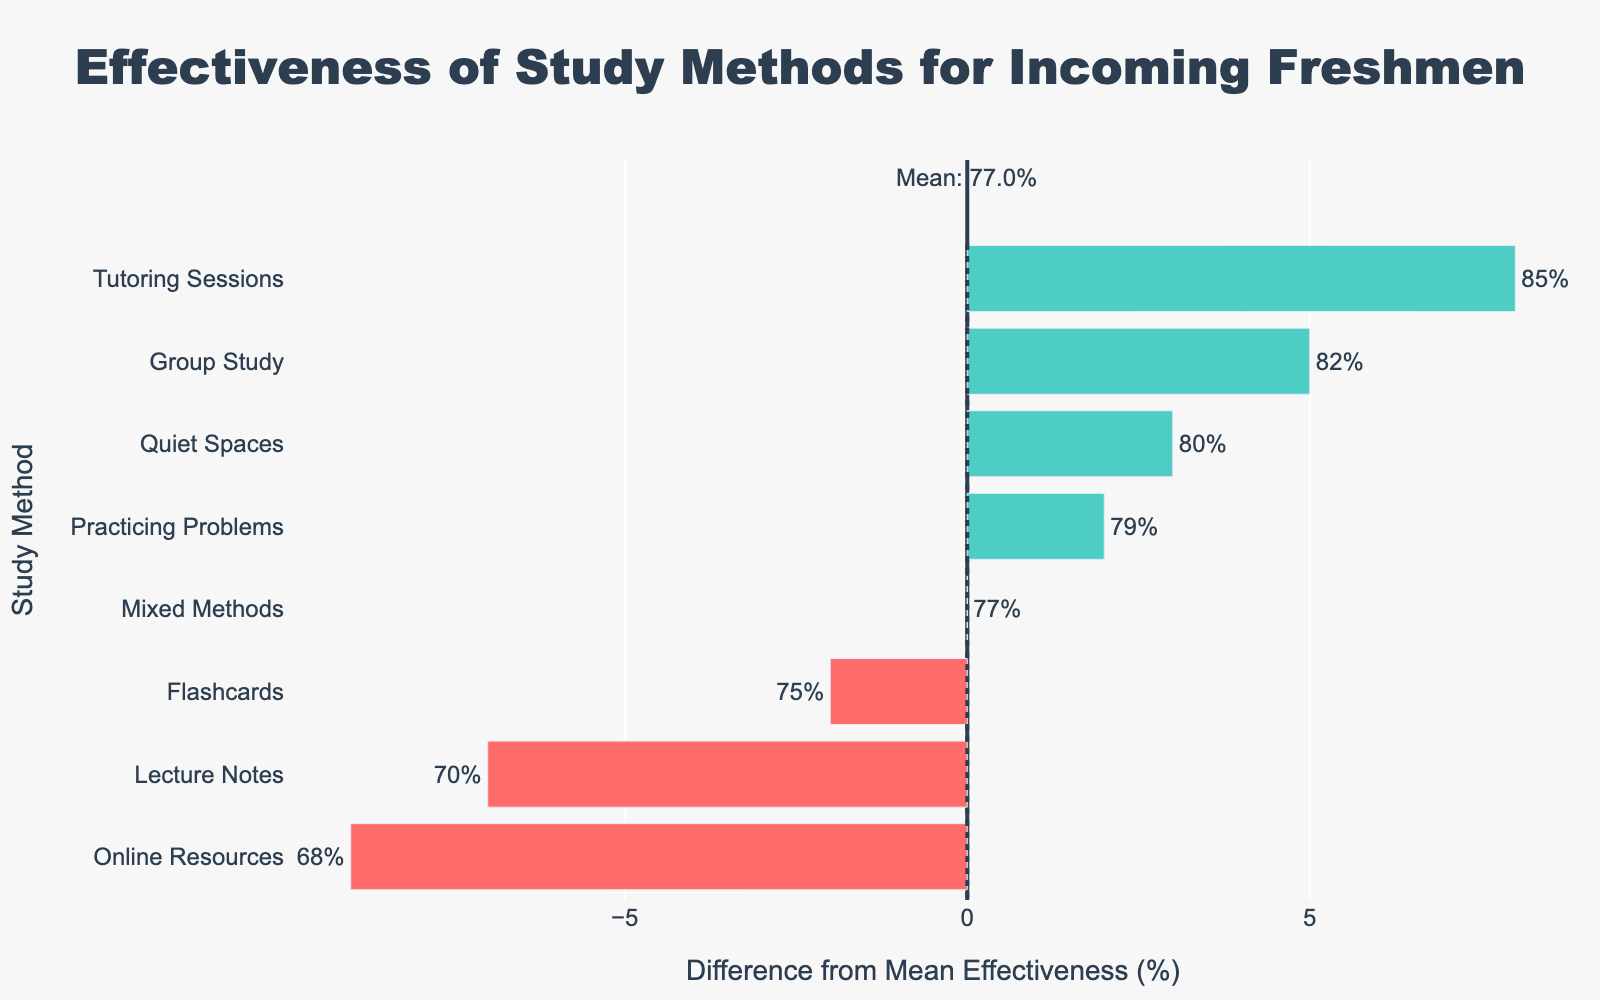What is the mean effectiveness of all study methods? The mean effectiveness is calculated by summing up all effectiveness percentages and dividing by the number of study methods. The sum of effectiveness percentages is 75 + 82 + 70 + 68 + 85 + 79 + 80 + 77 = 616. There are 8 study methods, so the mean effectiveness is 616 / 8 = 77%.
Answer: 77% Which study method has the highest effectiveness? Look at the bar with the highest positive length. The highest bar corresponds to "Tutoring Sessions" with an effectiveness of 85%.
Answer: Tutoring Sessions Which study method has an effectiveness closest to the mean? The mean effectiveness is 77%. Look for the bar that is closest to zero on either side of the mean line. "Mixed Methods" has an effectiveness of 77%, which is exactly the mean.
Answer: Mixed Methods Which study methods are less effective than the mean? Identify bars that are positioned left of the zero mean line. The study methods with effectiveness percentages less than 77% are "Lecture Notes" at 70%, "Online Resources" at 68%, and "Flashcards" at 75%.
Answer: Lecture Notes, Online Resources, Flashcards What is the combined effectiveness of "Practicing Problems" and "Tutoring Sessions"? The effectiveness of "Practicing Problems" is 79% and "Tutoring Sessions" is 85%. The combined effectiveness is 79 + 85 = 164%.
Answer: 164% Which study methods are in the green section of the bar chart? The green section indicates effectiveness above the mean. Study methods greater than 77% are "Group Study" at 82%, "Tutoring Sessions" at 85%, "Practicing Problems" at 79%, and "Quiet Spaces" at 80%.
Answer: Group Study, Tutoring Sessions, Practicing Problems, Quiet Spaces What is the effectiveness of the least effective study method? Look at the shortest bar. The least effective study method is "Online Resources" with an effectiveness of 68%.
Answer: 68% How far above the mean is the effectiveness of "Tutoring Sessions"? The mean effectiveness is 77%. "Tutoring Sessions" has an effectiveness of 85%. The difference is 85 - 77 = 8%.
Answer: 8% List the study methods in order of their effectiveness from lowest to highest. Sort the values of the effectiveness percentages in ascending order: Online Resources (68%), Lecture Notes (70%), Flashcards (75%), Mixed Methods (77%), Practicing Problems (79%), Quiet Spaces (80%), Group Study (82%), and Tutoring Sessions (85%).
Answer: Online Resources, Lecture Notes, Flashcards, Mixed Methods, Practicing Problems, Quiet Spaces, Group Study, Tutoring Sessions 